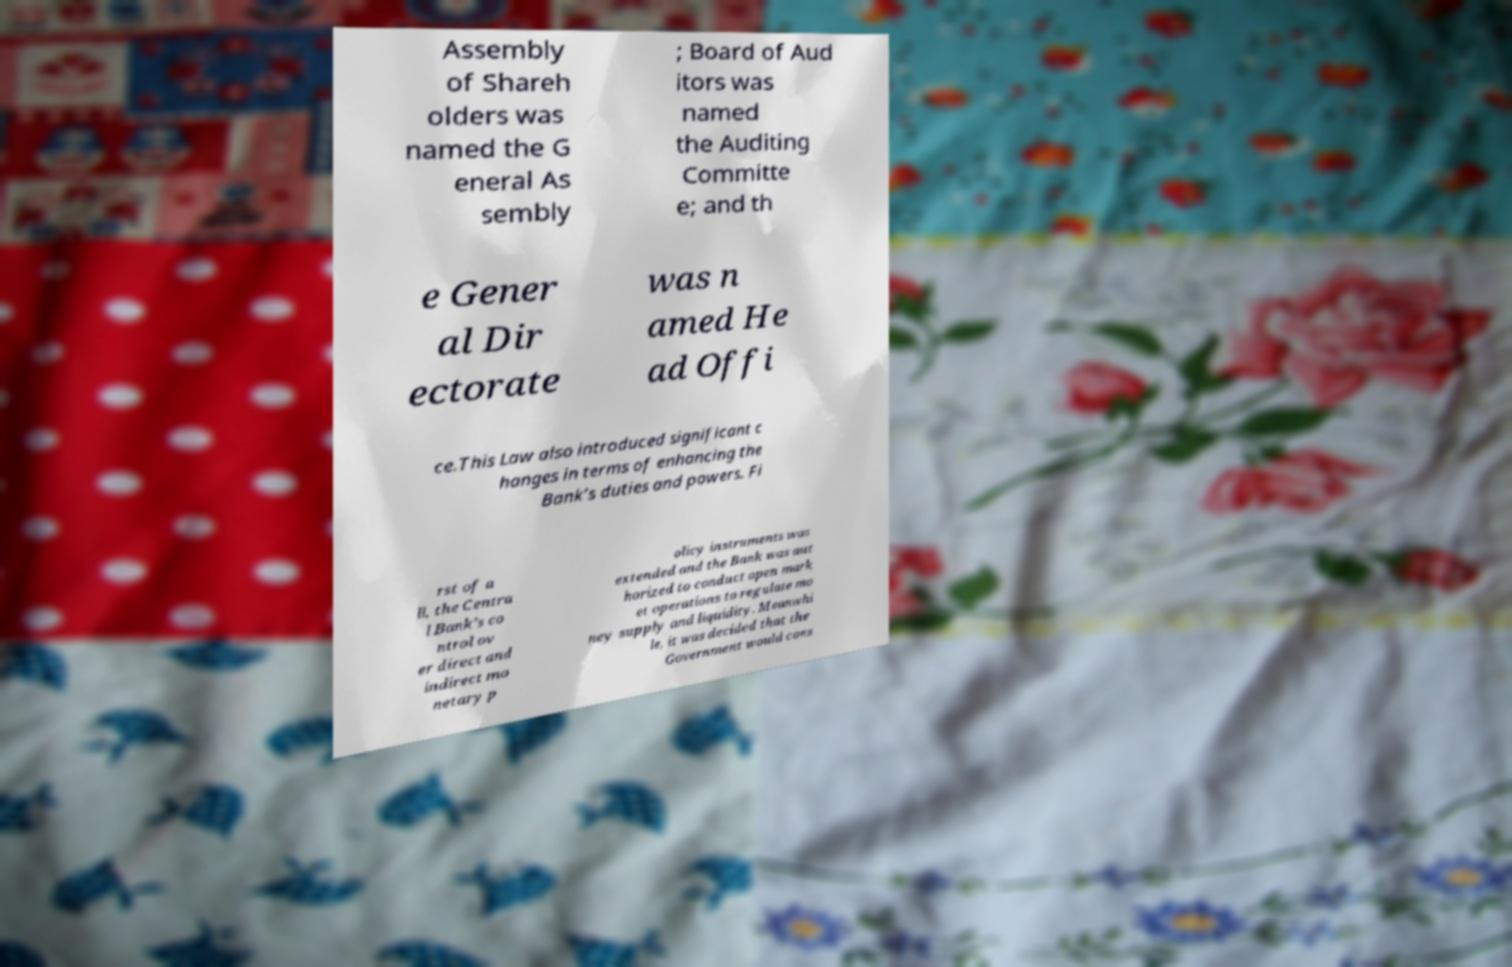What messages or text are displayed in this image? I need them in a readable, typed format. Assembly of Shareh olders was named the G eneral As sembly ; Board of Aud itors was named the Auditing Committe e; and th e Gener al Dir ectorate was n amed He ad Offi ce.This Law also introduced significant c hanges in terms of enhancing the Bank’s duties and powers. Fi rst of a ll, the Centra l Bank’s co ntrol ov er direct and indirect mo netary p olicy instruments was extended and the Bank was aut horized to conduct open mark et operations to regulate mo ney supply and liquidity. Meanwhi le, it was decided that the Government would cons 